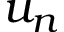Convert formula to latex. <formula><loc_0><loc_0><loc_500><loc_500>u _ { n }</formula> 